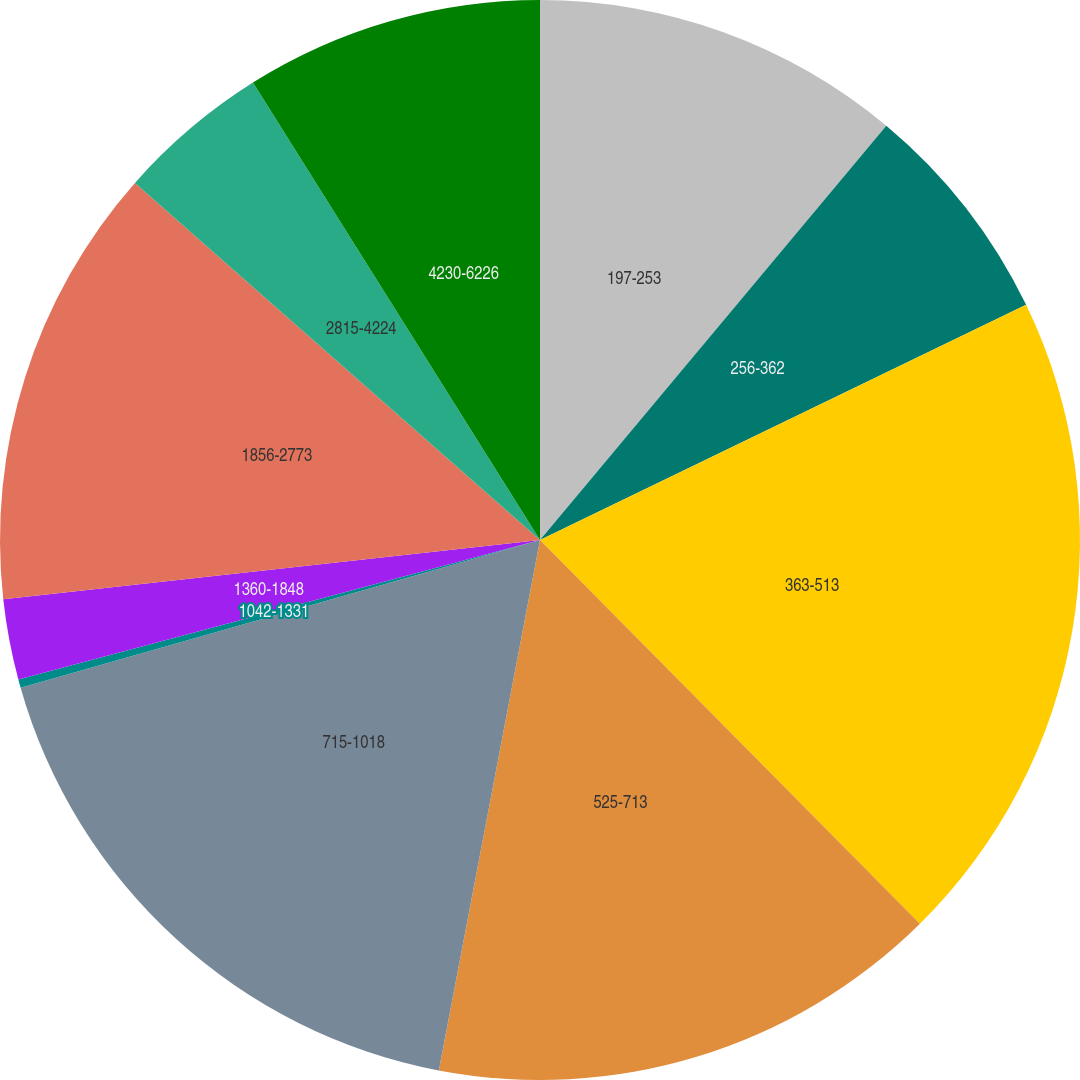<chart> <loc_0><loc_0><loc_500><loc_500><pie_chart><fcel>197-253<fcel>256-362<fcel>363-513<fcel>525-713<fcel>715-1018<fcel>1042-1331<fcel>1360-1848<fcel>1856-2773<fcel>2815-4224<fcel>4230-6226<nl><fcel>11.08%<fcel>6.75%<fcel>19.75%<fcel>15.42%<fcel>17.59%<fcel>0.25%<fcel>2.41%<fcel>13.25%<fcel>4.58%<fcel>8.92%<nl></chart> 